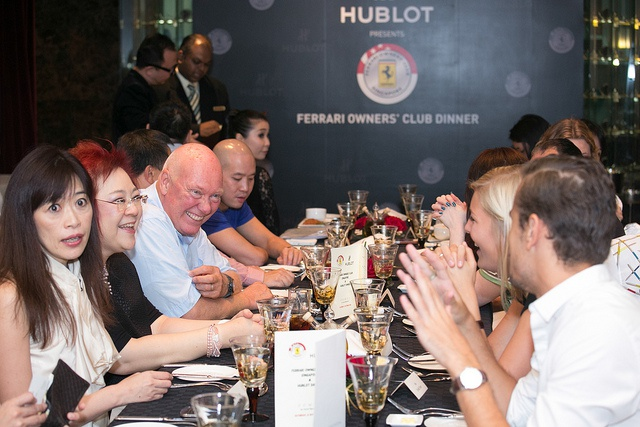Describe the objects in this image and their specific colors. I can see people in black, white, tan, and gray tones, people in black, tan, and lightgray tones, people in black, lavender, salmon, and brown tones, people in black, tan, and maroon tones, and people in black, tan, gray, and salmon tones in this image. 